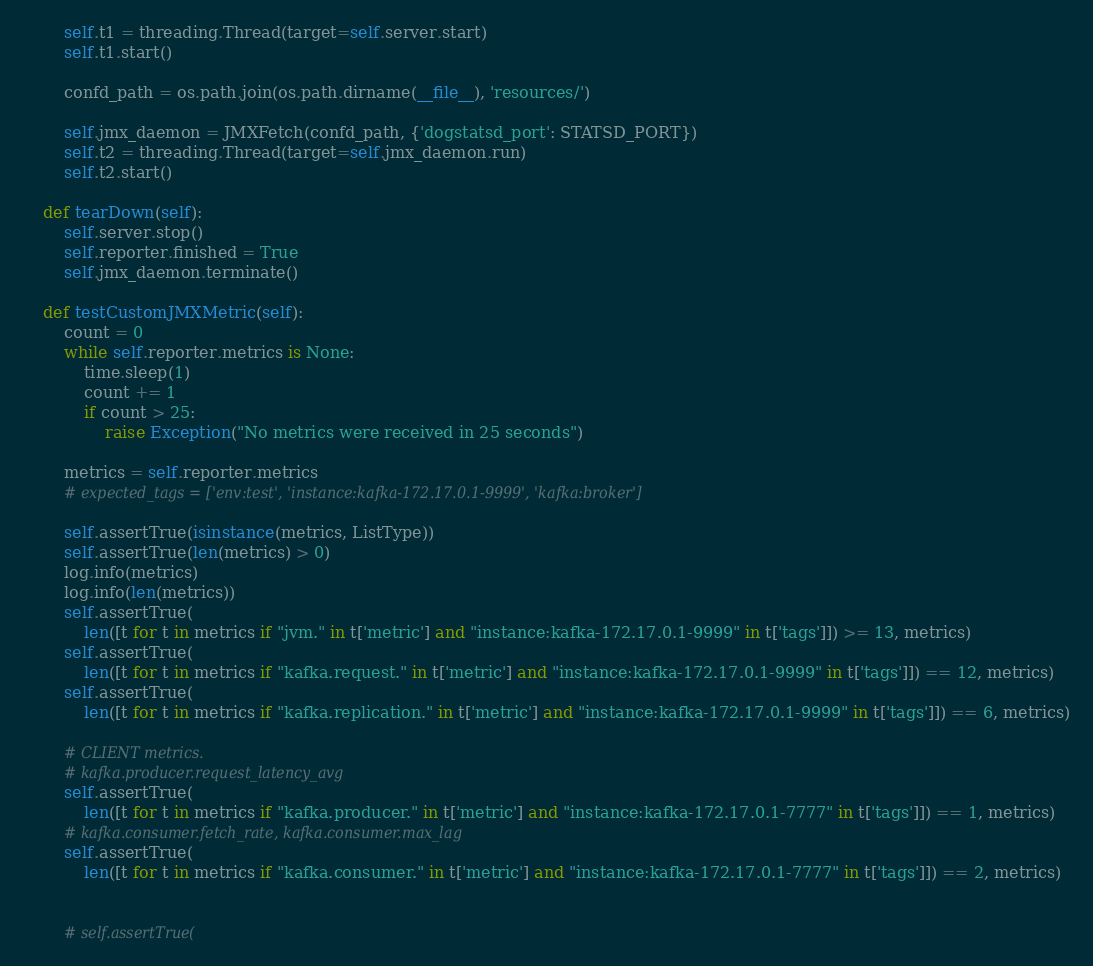Convert code to text. <code><loc_0><loc_0><loc_500><loc_500><_Python_>        self.t1 = threading.Thread(target=self.server.start)
        self.t1.start()

        confd_path = os.path.join(os.path.dirname(__file__), 'resources/')

        self.jmx_daemon = JMXFetch(confd_path, {'dogstatsd_port': STATSD_PORT})
        self.t2 = threading.Thread(target=self.jmx_daemon.run)
        self.t2.start()

    def tearDown(self):
        self.server.stop()
        self.reporter.finished = True
        self.jmx_daemon.terminate()

    def testCustomJMXMetric(self):
        count = 0
        while self.reporter.metrics is None:
            time.sleep(1)
            count += 1
            if count > 25:
                raise Exception("No metrics were received in 25 seconds")

        metrics = self.reporter.metrics
        # expected_tags = ['env:test', 'instance:kafka-172.17.0.1-9999', 'kafka:broker']

        self.assertTrue(isinstance(metrics, ListType))
        self.assertTrue(len(metrics) > 0)
        log.info(metrics)
        log.info(len(metrics))
        self.assertTrue(
            len([t for t in metrics if "jvm." in t['metric'] and "instance:kafka-172.17.0.1-9999" in t['tags']]) >= 13, metrics)
        self.assertTrue(
            len([t for t in metrics if "kafka.request." in t['metric'] and "instance:kafka-172.17.0.1-9999" in t['tags']]) == 12, metrics)
        self.assertTrue(
            len([t for t in metrics if "kafka.replication." in t['metric'] and "instance:kafka-172.17.0.1-9999" in t['tags']]) == 6, metrics)

        # CLIENT metrics.
        # kafka.producer.request_latency_avg
        self.assertTrue(
            len([t for t in metrics if "kafka.producer." in t['metric'] and "instance:kafka-172.17.0.1-7777" in t['tags']]) == 1, metrics)
        # kafka.consumer.fetch_rate, kafka.consumer.max_lag
        self.assertTrue(
            len([t for t in metrics if "kafka.consumer." in t['metric'] and "instance:kafka-172.17.0.1-7777" in t['tags']]) == 2, metrics)


        # self.assertTrue(</code> 